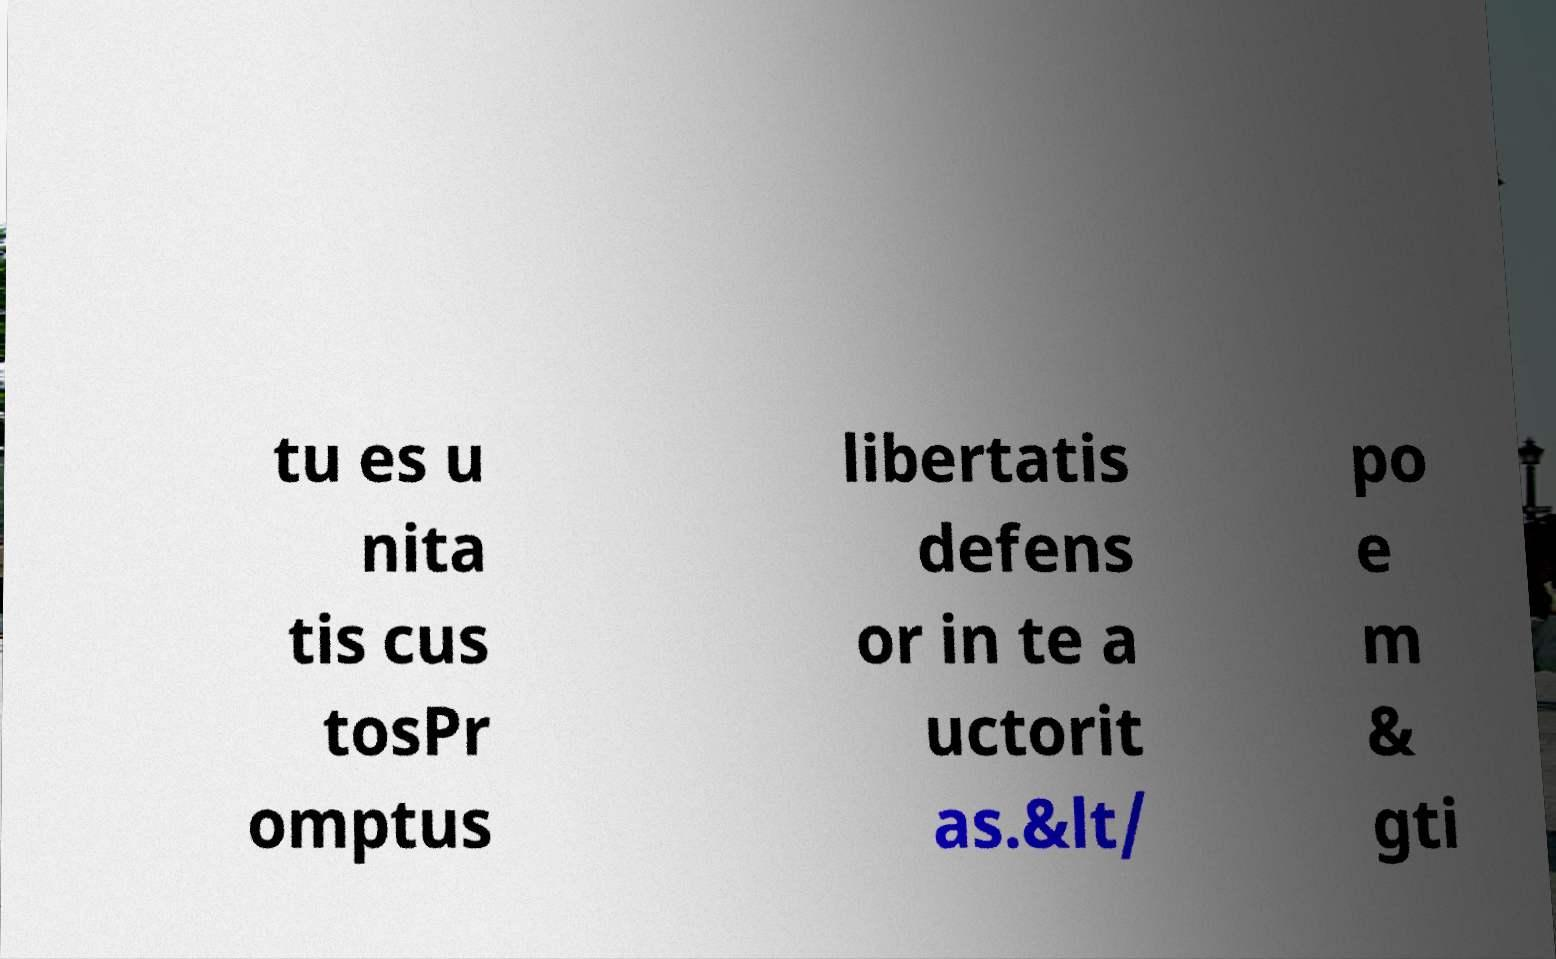What messages or text are displayed in this image? I need them in a readable, typed format. tu es u nita tis cus tosPr omptus libertatis defens or in te a uctorit as.&lt/ po e m & gti 